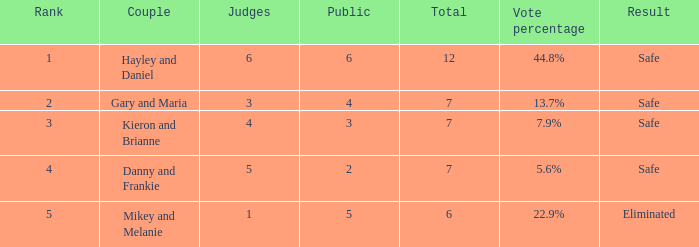What was the overall number when the voting percentage amounted to 44.8%? 1.0. 